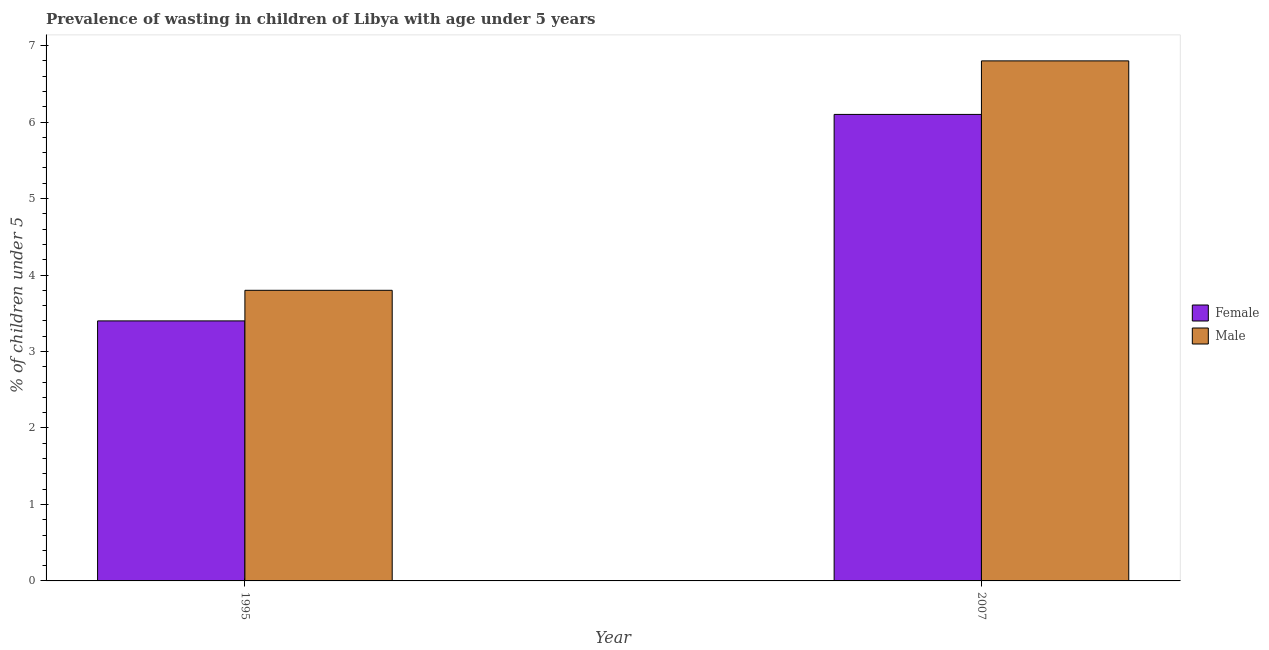How many different coloured bars are there?
Make the answer very short. 2. What is the label of the 1st group of bars from the left?
Offer a terse response. 1995. In how many cases, is the number of bars for a given year not equal to the number of legend labels?
Your response must be concise. 0. What is the percentage of undernourished female children in 2007?
Ensure brevity in your answer.  6.1. Across all years, what is the maximum percentage of undernourished male children?
Provide a short and direct response. 6.8. Across all years, what is the minimum percentage of undernourished female children?
Your response must be concise. 3.4. In which year was the percentage of undernourished male children maximum?
Keep it short and to the point. 2007. In which year was the percentage of undernourished female children minimum?
Your answer should be very brief. 1995. What is the total percentage of undernourished male children in the graph?
Offer a terse response. 10.6. What is the difference between the percentage of undernourished male children in 1995 and that in 2007?
Your response must be concise. -3. What is the difference between the percentage of undernourished female children in 1995 and the percentage of undernourished male children in 2007?
Ensure brevity in your answer.  -2.7. What is the average percentage of undernourished female children per year?
Your answer should be compact. 4.75. In the year 1995, what is the difference between the percentage of undernourished male children and percentage of undernourished female children?
Provide a succinct answer. 0. What is the ratio of the percentage of undernourished male children in 1995 to that in 2007?
Give a very brief answer. 0.56. What does the 1st bar from the right in 1995 represents?
Offer a terse response. Male. How many bars are there?
Provide a short and direct response. 4. How many years are there in the graph?
Your answer should be very brief. 2. Does the graph contain grids?
Keep it short and to the point. No. Where does the legend appear in the graph?
Your answer should be very brief. Center right. What is the title of the graph?
Make the answer very short. Prevalence of wasting in children of Libya with age under 5 years. Does "Grants" appear as one of the legend labels in the graph?
Make the answer very short. No. What is the label or title of the X-axis?
Offer a very short reply. Year. What is the label or title of the Y-axis?
Offer a very short reply.  % of children under 5. What is the  % of children under 5 of Female in 1995?
Ensure brevity in your answer.  3.4. What is the  % of children under 5 of Male in 1995?
Provide a succinct answer. 3.8. What is the  % of children under 5 of Female in 2007?
Keep it short and to the point. 6.1. What is the  % of children under 5 in Male in 2007?
Offer a very short reply. 6.8. Across all years, what is the maximum  % of children under 5 of Female?
Give a very brief answer. 6.1. Across all years, what is the maximum  % of children under 5 of Male?
Ensure brevity in your answer.  6.8. Across all years, what is the minimum  % of children under 5 of Female?
Ensure brevity in your answer.  3.4. Across all years, what is the minimum  % of children under 5 in Male?
Offer a very short reply. 3.8. What is the total  % of children under 5 of Male in the graph?
Offer a terse response. 10.6. What is the difference between the  % of children under 5 of Female in 1995 and that in 2007?
Give a very brief answer. -2.7. What is the average  % of children under 5 in Female per year?
Offer a terse response. 4.75. What is the average  % of children under 5 of Male per year?
Your response must be concise. 5.3. In the year 1995, what is the difference between the  % of children under 5 of Female and  % of children under 5 of Male?
Your response must be concise. -0.4. What is the ratio of the  % of children under 5 in Female in 1995 to that in 2007?
Your response must be concise. 0.56. What is the ratio of the  % of children under 5 of Male in 1995 to that in 2007?
Give a very brief answer. 0.56. What is the difference between the highest and the second highest  % of children under 5 in Female?
Provide a succinct answer. 2.7. What is the difference between the highest and the lowest  % of children under 5 of Female?
Make the answer very short. 2.7. What is the difference between the highest and the lowest  % of children under 5 of Male?
Ensure brevity in your answer.  3. 